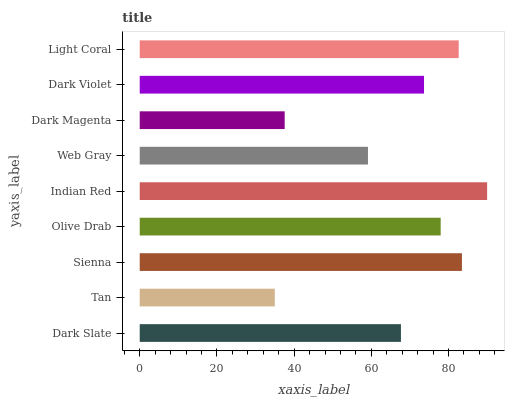Is Tan the minimum?
Answer yes or no. Yes. Is Indian Red the maximum?
Answer yes or no. Yes. Is Sienna the minimum?
Answer yes or no. No. Is Sienna the maximum?
Answer yes or no. No. Is Sienna greater than Tan?
Answer yes or no. Yes. Is Tan less than Sienna?
Answer yes or no. Yes. Is Tan greater than Sienna?
Answer yes or no. No. Is Sienna less than Tan?
Answer yes or no. No. Is Dark Violet the high median?
Answer yes or no. Yes. Is Dark Violet the low median?
Answer yes or no. Yes. Is Olive Drab the high median?
Answer yes or no. No. Is Web Gray the low median?
Answer yes or no. No. 